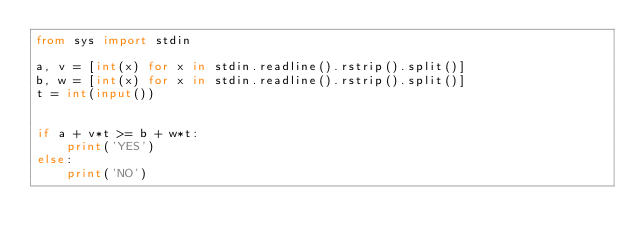Convert code to text. <code><loc_0><loc_0><loc_500><loc_500><_Python_>from sys import stdin

a, v = [int(x) for x in stdin.readline().rstrip().split()]
b, w = [int(x) for x in stdin.readline().rstrip().split()]
t = int(input())


if a + v*t >= b + w*t:
    print('YES')
else:
    print('NO')</code> 